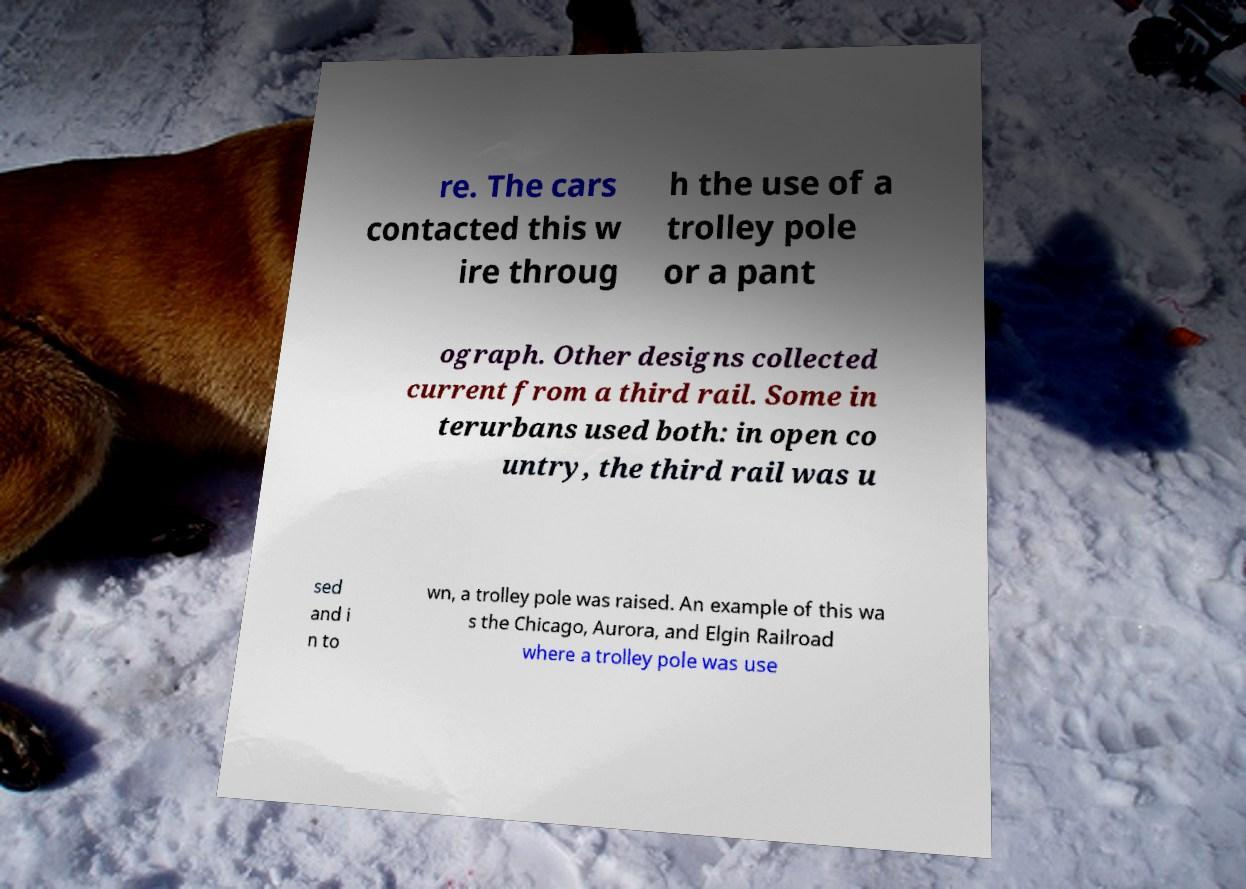Please identify and transcribe the text found in this image. re. The cars contacted this w ire throug h the use of a trolley pole or a pant ograph. Other designs collected current from a third rail. Some in terurbans used both: in open co untry, the third rail was u sed and i n to wn, a trolley pole was raised. An example of this wa s the Chicago, Aurora, and Elgin Railroad where a trolley pole was use 